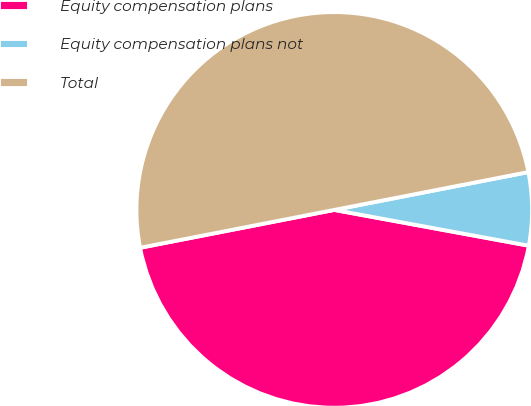<chart> <loc_0><loc_0><loc_500><loc_500><pie_chart><fcel>Equity compensation plans<fcel>Equity compensation plans not<fcel>Total<nl><fcel>44.04%<fcel>5.96%<fcel>50.0%<nl></chart> 